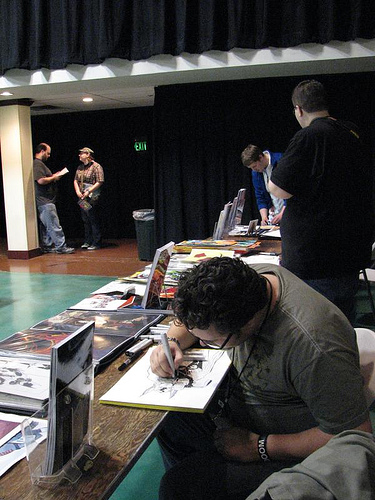<image>
Is there a man to the right of the man? Yes. From this viewpoint, the man is positioned to the right side relative to the man. 